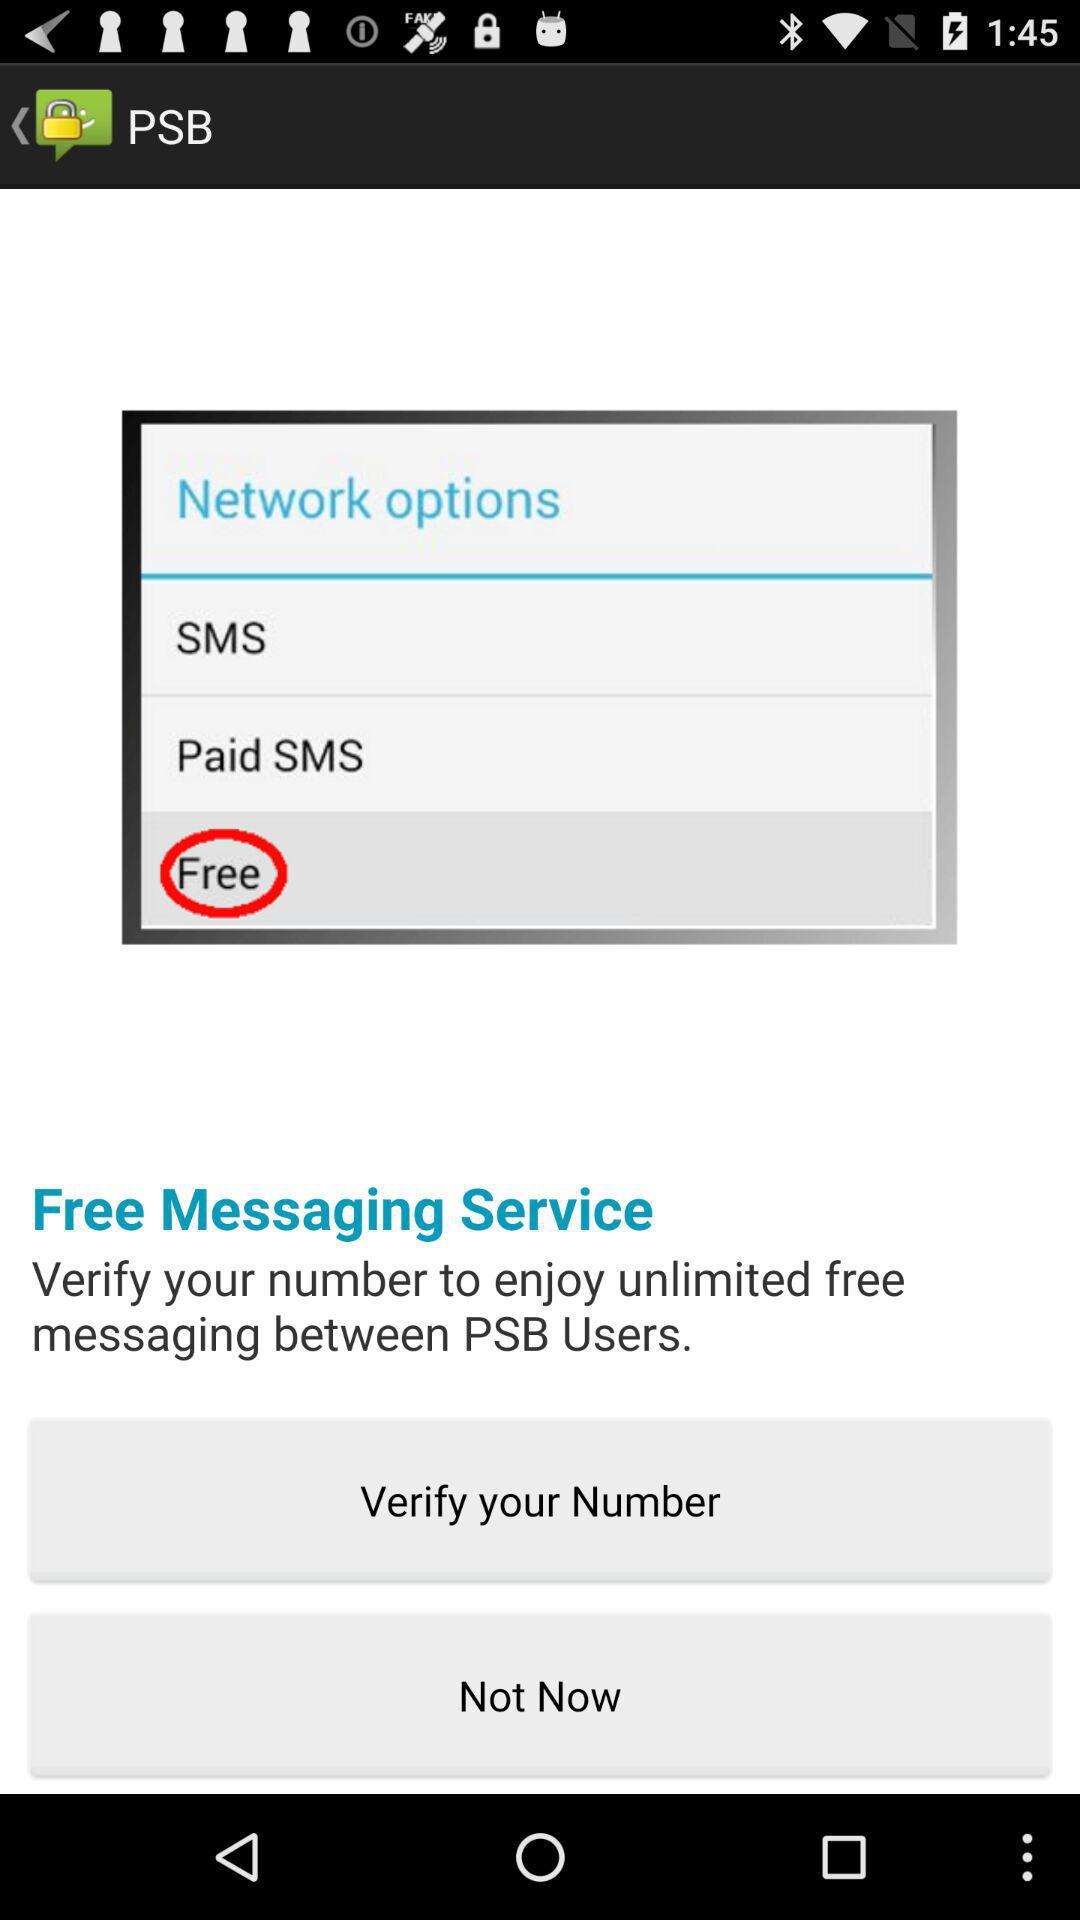How many options are free?
Answer the question using a single word or phrase. 2 